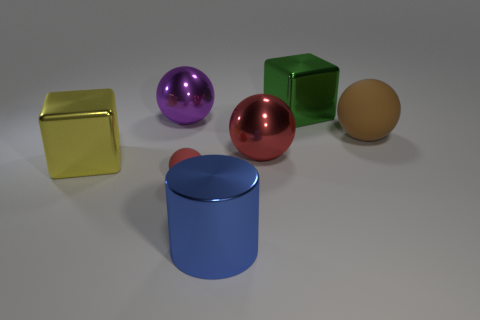Can you tell me the colors of the objects present in the image? Certainly! In the image, there is a yellow cube, a purple sphere, a red sphere, a green cube, a blue cylinder, and an egg-colored sphere. 